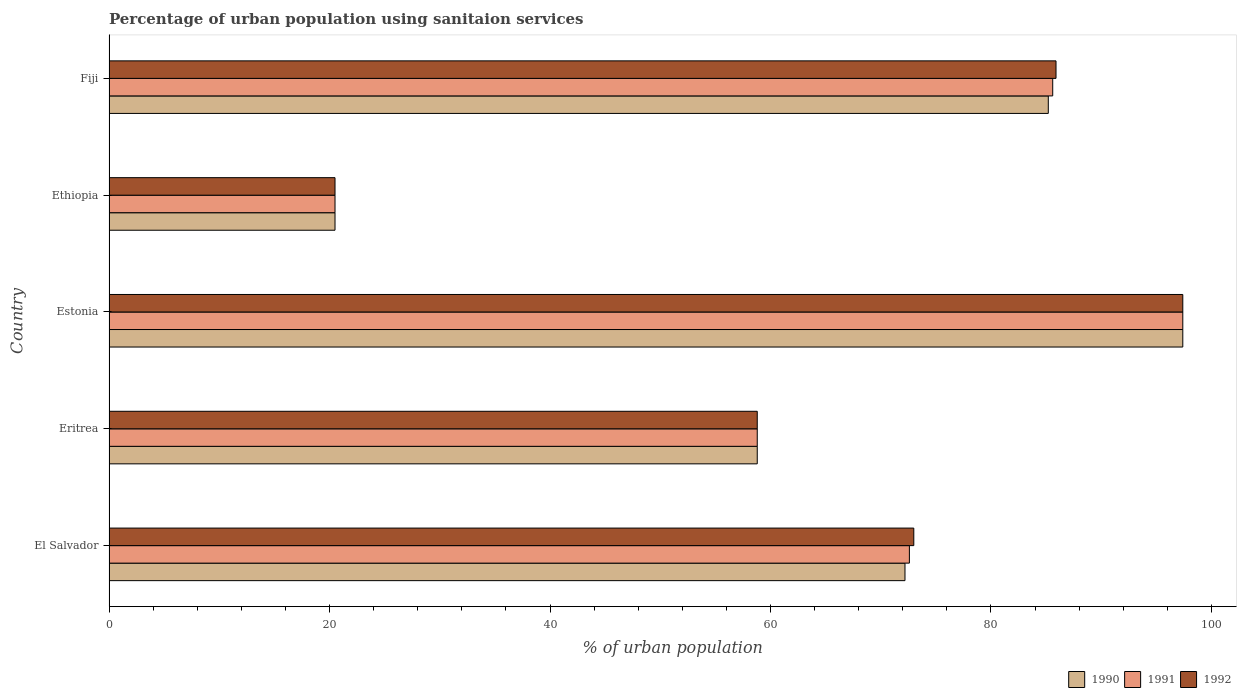How many different coloured bars are there?
Keep it short and to the point. 3. Are the number of bars per tick equal to the number of legend labels?
Your answer should be compact. Yes. What is the label of the 4th group of bars from the top?
Provide a short and direct response. Eritrea. In how many cases, is the number of bars for a given country not equal to the number of legend labels?
Give a very brief answer. 0. What is the percentage of urban population using sanitaion services in 1991 in Eritrea?
Provide a succinct answer. 58.8. Across all countries, what is the maximum percentage of urban population using sanitaion services in 1991?
Provide a succinct answer. 97.4. Across all countries, what is the minimum percentage of urban population using sanitaion services in 1990?
Give a very brief answer. 20.5. In which country was the percentage of urban population using sanitaion services in 1990 maximum?
Offer a terse response. Estonia. In which country was the percentage of urban population using sanitaion services in 1992 minimum?
Offer a terse response. Ethiopia. What is the total percentage of urban population using sanitaion services in 1992 in the graph?
Ensure brevity in your answer.  335.6. What is the difference between the percentage of urban population using sanitaion services in 1992 in El Salvador and that in Fiji?
Provide a succinct answer. -12.9. What is the difference between the percentage of urban population using sanitaion services in 1992 in Eritrea and the percentage of urban population using sanitaion services in 1990 in Ethiopia?
Offer a very short reply. 38.3. What is the average percentage of urban population using sanitaion services in 1990 per country?
Your response must be concise. 66.82. What is the difference between the percentage of urban population using sanitaion services in 1990 and percentage of urban population using sanitaion services in 1991 in El Salvador?
Give a very brief answer. -0.4. In how many countries, is the percentage of urban population using sanitaion services in 1992 greater than 88 %?
Offer a very short reply. 1. What is the ratio of the percentage of urban population using sanitaion services in 1992 in El Salvador to that in Estonia?
Offer a terse response. 0.75. What is the difference between the highest and the second highest percentage of urban population using sanitaion services in 1990?
Keep it short and to the point. 12.2. What is the difference between the highest and the lowest percentage of urban population using sanitaion services in 1991?
Your answer should be very brief. 76.9. What does the 2nd bar from the top in El Salvador represents?
Give a very brief answer. 1991. Are all the bars in the graph horizontal?
Your response must be concise. Yes. How many countries are there in the graph?
Keep it short and to the point. 5. What is the difference between two consecutive major ticks on the X-axis?
Give a very brief answer. 20. Are the values on the major ticks of X-axis written in scientific E-notation?
Your answer should be very brief. No. Does the graph contain grids?
Your response must be concise. No. Where does the legend appear in the graph?
Keep it short and to the point. Bottom right. How many legend labels are there?
Offer a terse response. 3. How are the legend labels stacked?
Ensure brevity in your answer.  Horizontal. What is the title of the graph?
Provide a short and direct response. Percentage of urban population using sanitaion services. What is the label or title of the X-axis?
Give a very brief answer. % of urban population. What is the % of urban population of 1990 in El Salvador?
Ensure brevity in your answer.  72.2. What is the % of urban population of 1991 in El Salvador?
Provide a succinct answer. 72.6. What is the % of urban population of 1990 in Eritrea?
Offer a terse response. 58.8. What is the % of urban population in 1991 in Eritrea?
Offer a terse response. 58.8. What is the % of urban population of 1992 in Eritrea?
Ensure brevity in your answer.  58.8. What is the % of urban population of 1990 in Estonia?
Offer a terse response. 97.4. What is the % of urban population of 1991 in Estonia?
Provide a succinct answer. 97.4. What is the % of urban population in 1992 in Estonia?
Your answer should be very brief. 97.4. What is the % of urban population of 1992 in Ethiopia?
Your response must be concise. 20.5. What is the % of urban population in 1990 in Fiji?
Give a very brief answer. 85.2. What is the % of urban population of 1991 in Fiji?
Offer a terse response. 85.6. What is the % of urban population in 1992 in Fiji?
Your answer should be very brief. 85.9. Across all countries, what is the maximum % of urban population in 1990?
Keep it short and to the point. 97.4. Across all countries, what is the maximum % of urban population of 1991?
Ensure brevity in your answer.  97.4. Across all countries, what is the maximum % of urban population of 1992?
Offer a terse response. 97.4. What is the total % of urban population in 1990 in the graph?
Provide a succinct answer. 334.1. What is the total % of urban population in 1991 in the graph?
Provide a short and direct response. 334.9. What is the total % of urban population of 1992 in the graph?
Make the answer very short. 335.6. What is the difference between the % of urban population in 1990 in El Salvador and that in Eritrea?
Ensure brevity in your answer.  13.4. What is the difference between the % of urban population in 1992 in El Salvador and that in Eritrea?
Your response must be concise. 14.2. What is the difference between the % of urban population in 1990 in El Salvador and that in Estonia?
Make the answer very short. -25.2. What is the difference between the % of urban population in 1991 in El Salvador and that in Estonia?
Provide a short and direct response. -24.8. What is the difference between the % of urban population of 1992 in El Salvador and that in Estonia?
Offer a very short reply. -24.4. What is the difference between the % of urban population of 1990 in El Salvador and that in Ethiopia?
Give a very brief answer. 51.7. What is the difference between the % of urban population of 1991 in El Salvador and that in Ethiopia?
Give a very brief answer. 52.1. What is the difference between the % of urban population in 1992 in El Salvador and that in Ethiopia?
Your answer should be very brief. 52.5. What is the difference between the % of urban population in 1991 in El Salvador and that in Fiji?
Your response must be concise. -13. What is the difference between the % of urban population in 1992 in El Salvador and that in Fiji?
Your answer should be compact. -12.9. What is the difference between the % of urban population of 1990 in Eritrea and that in Estonia?
Provide a succinct answer. -38.6. What is the difference between the % of urban population of 1991 in Eritrea and that in Estonia?
Your answer should be compact. -38.6. What is the difference between the % of urban population of 1992 in Eritrea and that in Estonia?
Provide a short and direct response. -38.6. What is the difference between the % of urban population of 1990 in Eritrea and that in Ethiopia?
Your answer should be compact. 38.3. What is the difference between the % of urban population of 1991 in Eritrea and that in Ethiopia?
Your response must be concise. 38.3. What is the difference between the % of urban population of 1992 in Eritrea and that in Ethiopia?
Your answer should be compact. 38.3. What is the difference between the % of urban population of 1990 in Eritrea and that in Fiji?
Make the answer very short. -26.4. What is the difference between the % of urban population of 1991 in Eritrea and that in Fiji?
Give a very brief answer. -26.8. What is the difference between the % of urban population of 1992 in Eritrea and that in Fiji?
Provide a short and direct response. -27.1. What is the difference between the % of urban population of 1990 in Estonia and that in Ethiopia?
Give a very brief answer. 76.9. What is the difference between the % of urban population of 1991 in Estonia and that in Ethiopia?
Your answer should be very brief. 76.9. What is the difference between the % of urban population of 1992 in Estonia and that in Ethiopia?
Make the answer very short. 76.9. What is the difference between the % of urban population of 1990 in Estonia and that in Fiji?
Your answer should be compact. 12.2. What is the difference between the % of urban population of 1992 in Estonia and that in Fiji?
Keep it short and to the point. 11.5. What is the difference between the % of urban population of 1990 in Ethiopia and that in Fiji?
Offer a very short reply. -64.7. What is the difference between the % of urban population of 1991 in Ethiopia and that in Fiji?
Ensure brevity in your answer.  -65.1. What is the difference between the % of urban population in 1992 in Ethiopia and that in Fiji?
Give a very brief answer. -65.4. What is the difference between the % of urban population of 1990 in El Salvador and the % of urban population of 1992 in Eritrea?
Offer a very short reply. 13.4. What is the difference between the % of urban population in 1991 in El Salvador and the % of urban population in 1992 in Eritrea?
Your response must be concise. 13.8. What is the difference between the % of urban population of 1990 in El Salvador and the % of urban population of 1991 in Estonia?
Give a very brief answer. -25.2. What is the difference between the % of urban population of 1990 in El Salvador and the % of urban population of 1992 in Estonia?
Your answer should be very brief. -25.2. What is the difference between the % of urban population in 1991 in El Salvador and the % of urban population in 1992 in Estonia?
Your response must be concise. -24.8. What is the difference between the % of urban population of 1990 in El Salvador and the % of urban population of 1991 in Ethiopia?
Your response must be concise. 51.7. What is the difference between the % of urban population of 1990 in El Salvador and the % of urban population of 1992 in Ethiopia?
Provide a short and direct response. 51.7. What is the difference between the % of urban population of 1991 in El Salvador and the % of urban population of 1992 in Ethiopia?
Ensure brevity in your answer.  52.1. What is the difference between the % of urban population in 1990 in El Salvador and the % of urban population in 1991 in Fiji?
Your answer should be compact. -13.4. What is the difference between the % of urban population of 1990 in El Salvador and the % of urban population of 1992 in Fiji?
Keep it short and to the point. -13.7. What is the difference between the % of urban population of 1991 in El Salvador and the % of urban population of 1992 in Fiji?
Make the answer very short. -13.3. What is the difference between the % of urban population of 1990 in Eritrea and the % of urban population of 1991 in Estonia?
Your answer should be compact. -38.6. What is the difference between the % of urban population of 1990 in Eritrea and the % of urban population of 1992 in Estonia?
Provide a short and direct response. -38.6. What is the difference between the % of urban population of 1991 in Eritrea and the % of urban population of 1992 in Estonia?
Make the answer very short. -38.6. What is the difference between the % of urban population of 1990 in Eritrea and the % of urban population of 1991 in Ethiopia?
Your answer should be compact. 38.3. What is the difference between the % of urban population in 1990 in Eritrea and the % of urban population in 1992 in Ethiopia?
Your response must be concise. 38.3. What is the difference between the % of urban population in 1991 in Eritrea and the % of urban population in 1992 in Ethiopia?
Give a very brief answer. 38.3. What is the difference between the % of urban population of 1990 in Eritrea and the % of urban population of 1991 in Fiji?
Ensure brevity in your answer.  -26.8. What is the difference between the % of urban population in 1990 in Eritrea and the % of urban population in 1992 in Fiji?
Offer a terse response. -27.1. What is the difference between the % of urban population of 1991 in Eritrea and the % of urban population of 1992 in Fiji?
Give a very brief answer. -27.1. What is the difference between the % of urban population in 1990 in Estonia and the % of urban population in 1991 in Ethiopia?
Keep it short and to the point. 76.9. What is the difference between the % of urban population in 1990 in Estonia and the % of urban population in 1992 in Ethiopia?
Offer a very short reply. 76.9. What is the difference between the % of urban population in 1991 in Estonia and the % of urban population in 1992 in Ethiopia?
Ensure brevity in your answer.  76.9. What is the difference between the % of urban population of 1990 in Estonia and the % of urban population of 1991 in Fiji?
Keep it short and to the point. 11.8. What is the difference between the % of urban population of 1991 in Estonia and the % of urban population of 1992 in Fiji?
Offer a very short reply. 11.5. What is the difference between the % of urban population in 1990 in Ethiopia and the % of urban population in 1991 in Fiji?
Your answer should be compact. -65.1. What is the difference between the % of urban population of 1990 in Ethiopia and the % of urban population of 1992 in Fiji?
Ensure brevity in your answer.  -65.4. What is the difference between the % of urban population in 1991 in Ethiopia and the % of urban population in 1992 in Fiji?
Provide a succinct answer. -65.4. What is the average % of urban population of 1990 per country?
Keep it short and to the point. 66.82. What is the average % of urban population in 1991 per country?
Give a very brief answer. 66.98. What is the average % of urban population of 1992 per country?
Ensure brevity in your answer.  67.12. What is the difference between the % of urban population in 1990 and % of urban population in 1991 in El Salvador?
Your answer should be very brief. -0.4. What is the difference between the % of urban population of 1990 and % of urban population of 1992 in Eritrea?
Your response must be concise. 0. What is the difference between the % of urban population of 1990 and % of urban population of 1992 in Ethiopia?
Offer a terse response. 0. What is the difference between the % of urban population of 1990 and % of urban population of 1991 in Fiji?
Your answer should be compact. -0.4. What is the difference between the % of urban population in 1990 and % of urban population in 1992 in Fiji?
Keep it short and to the point. -0.7. What is the ratio of the % of urban population in 1990 in El Salvador to that in Eritrea?
Your answer should be very brief. 1.23. What is the ratio of the % of urban population of 1991 in El Salvador to that in Eritrea?
Make the answer very short. 1.23. What is the ratio of the % of urban population of 1992 in El Salvador to that in Eritrea?
Offer a very short reply. 1.24. What is the ratio of the % of urban population in 1990 in El Salvador to that in Estonia?
Make the answer very short. 0.74. What is the ratio of the % of urban population of 1991 in El Salvador to that in Estonia?
Provide a short and direct response. 0.75. What is the ratio of the % of urban population in 1992 in El Salvador to that in Estonia?
Your answer should be compact. 0.75. What is the ratio of the % of urban population of 1990 in El Salvador to that in Ethiopia?
Provide a short and direct response. 3.52. What is the ratio of the % of urban population of 1991 in El Salvador to that in Ethiopia?
Offer a terse response. 3.54. What is the ratio of the % of urban population in 1992 in El Salvador to that in Ethiopia?
Keep it short and to the point. 3.56. What is the ratio of the % of urban population in 1990 in El Salvador to that in Fiji?
Offer a very short reply. 0.85. What is the ratio of the % of urban population of 1991 in El Salvador to that in Fiji?
Provide a short and direct response. 0.85. What is the ratio of the % of urban population in 1992 in El Salvador to that in Fiji?
Offer a very short reply. 0.85. What is the ratio of the % of urban population of 1990 in Eritrea to that in Estonia?
Make the answer very short. 0.6. What is the ratio of the % of urban population in 1991 in Eritrea to that in Estonia?
Your response must be concise. 0.6. What is the ratio of the % of urban population in 1992 in Eritrea to that in Estonia?
Keep it short and to the point. 0.6. What is the ratio of the % of urban population of 1990 in Eritrea to that in Ethiopia?
Give a very brief answer. 2.87. What is the ratio of the % of urban population of 1991 in Eritrea to that in Ethiopia?
Offer a terse response. 2.87. What is the ratio of the % of urban population of 1992 in Eritrea to that in Ethiopia?
Keep it short and to the point. 2.87. What is the ratio of the % of urban population of 1990 in Eritrea to that in Fiji?
Your response must be concise. 0.69. What is the ratio of the % of urban population in 1991 in Eritrea to that in Fiji?
Offer a very short reply. 0.69. What is the ratio of the % of urban population of 1992 in Eritrea to that in Fiji?
Ensure brevity in your answer.  0.68. What is the ratio of the % of urban population in 1990 in Estonia to that in Ethiopia?
Give a very brief answer. 4.75. What is the ratio of the % of urban population of 1991 in Estonia to that in Ethiopia?
Offer a very short reply. 4.75. What is the ratio of the % of urban population of 1992 in Estonia to that in Ethiopia?
Provide a succinct answer. 4.75. What is the ratio of the % of urban population in 1990 in Estonia to that in Fiji?
Ensure brevity in your answer.  1.14. What is the ratio of the % of urban population in 1991 in Estonia to that in Fiji?
Make the answer very short. 1.14. What is the ratio of the % of urban population of 1992 in Estonia to that in Fiji?
Provide a succinct answer. 1.13. What is the ratio of the % of urban population of 1990 in Ethiopia to that in Fiji?
Provide a short and direct response. 0.24. What is the ratio of the % of urban population of 1991 in Ethiopia to that in Fiji?
Offer a very short reply. 0.24. What is the ratio of the % of urban population in 1992 in Ethiopia to that in Fiji?
Provide a short and direct response. 0.24. What is the difference between the highest and the lowest % of urban population of 1990?
Ensure brevity in your answer.  76.9. What is the difference between the highest and the lowest % of urban population in 1991?
Ensure brevity in your answer.  76.9. What is the difference between the highest and the lowest % of urban population in 1992?
Ensure brevity in your answer.  76.9. 